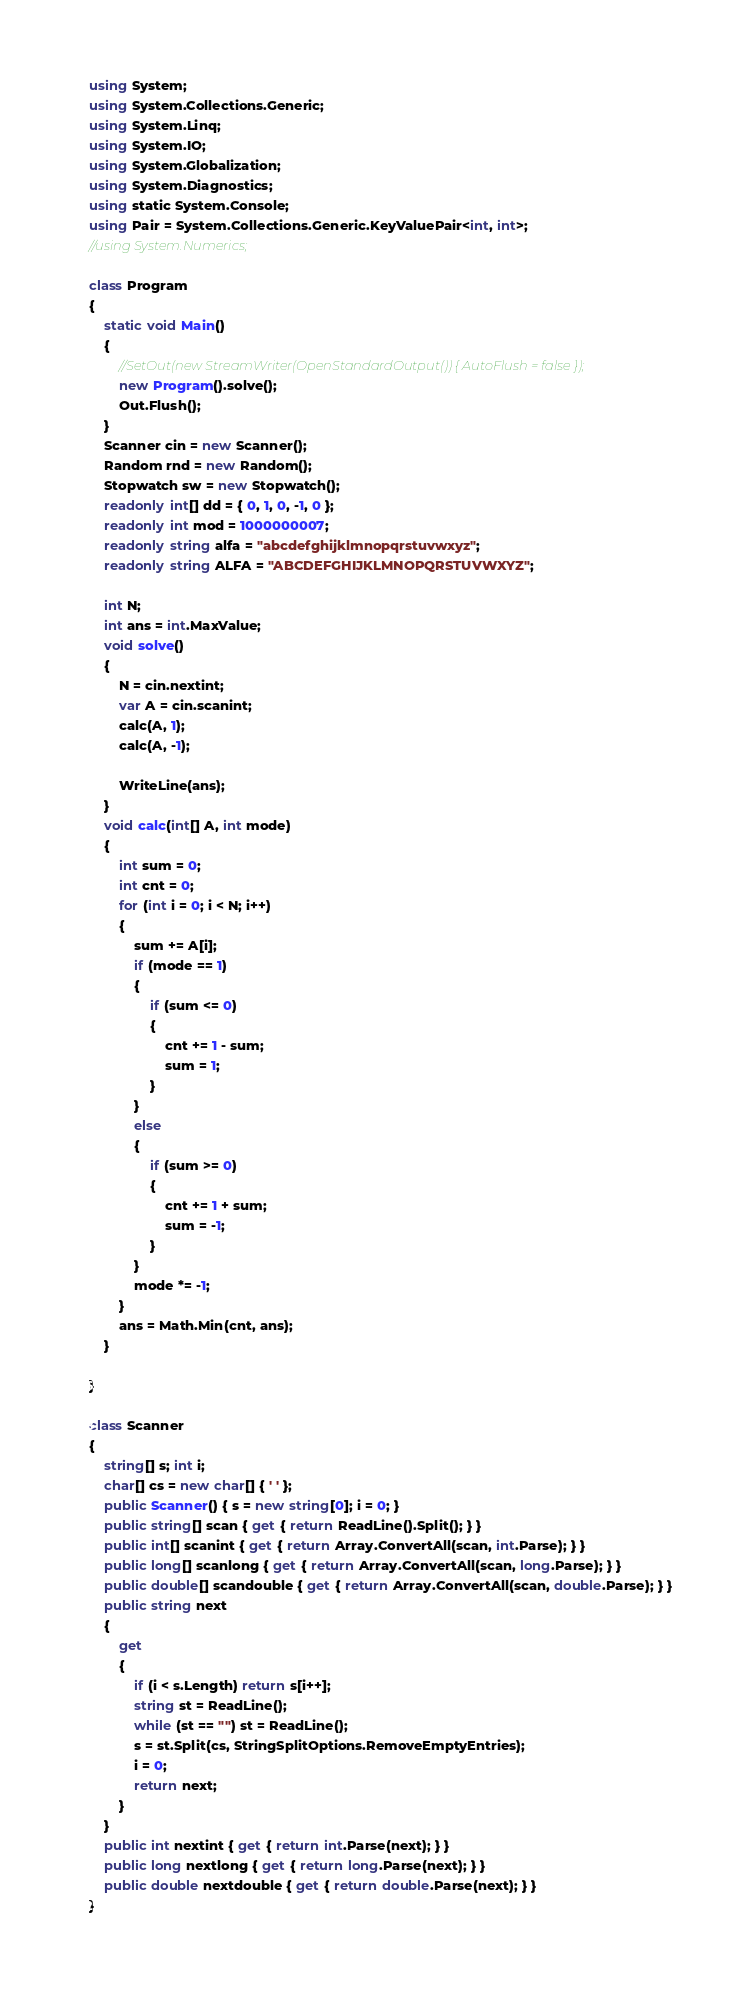<code> <loc_0><loc_0><loc_500><loc_500><_C#_>using System;
using System.Collections.Generic;
using System.Linq;
using System.IO;
using System.Globalization;
using System.Diagnostics;
using static System.Console;
using Pair = System.Collections.Generic.KeyValuePair<int, int>;
//using System.Numerics;

class Program
{
    static void Main()
    {
        //SetOut(new StreamWriter(OpenStandardOutput()) { AutoFlush = false });
        new Program().solve();
        Out.Flush();
    }
    Scanner cin = new Scanner();
    Random rnd = new Random();
    Stopwatch sw = new Stopwatch();
    readonly int[] dd = { 0, 1, 0, -1, 0 };
    readonly int mod = 1000000007;
    readonly string alfa = "abcdefghijklmnopqrstuvwxyz";
    readonly string ALFA = "ABCDEFGHIJKLMNOPQRSTUVWXYZ";

    int N;
    int ans = int.MaxValue;
    void solve()
    {
        N = cin.nextint;
        var A = cin.scanint;
        calc(A, 1);
        calc(A, -1);

        WriteLine(ans);
    }
    void calc(int[] A, int mode)
    {
        int sum = 0;
        int cnt = 0;
        for (int i = 0; i < N; i++)
        {
            sum += A[i];
            if (mode == 1)
            {
                if (sum <= 0)
                {
                    cnt += 1 - sum;
                    sum = 1;
                }
            }
            else
            {
                if (sum >= 0)
                {
                    cnt += 1 + sum;
                    sum = -1;
                }
            }
            mode *= -1;
        }
        ans = Math.Min(cnt, ans);
    }

}

class Scanner
{
    string[] s; int i;
    char[] cs = new char[] { ' ' };
    public Scanner() { s = new string[0]; i = 0; }
    public string[] scan { get { return ReadLine().Split(); } }
    public int[] scanint { get { return Array.ConvertAll(scan, int.Parse); } }
    public long[] scanlong { get { return Array.ConvertAll(scan, long.Parse); } }
    public double[] scandouble { get { return Array.ConvertAll(scan, double.Parse); } }
    public string next
    {
        get
        {
            if (i < s.Length) return s[i++];
            string st = ReadLine();
            while (st == "") st = ReadLine();
            s = st.Split(cs, StringSplitOptions.RemoveEmptyEntries);
            i = 0;
            return next;
        }
    }
    public int nextint { get { return int.Parse(next); } }
    public long nextlong { get { return long.Parse(next); } }
    public double nextdouble { get { return double.Parse(next); } }
}</code> 